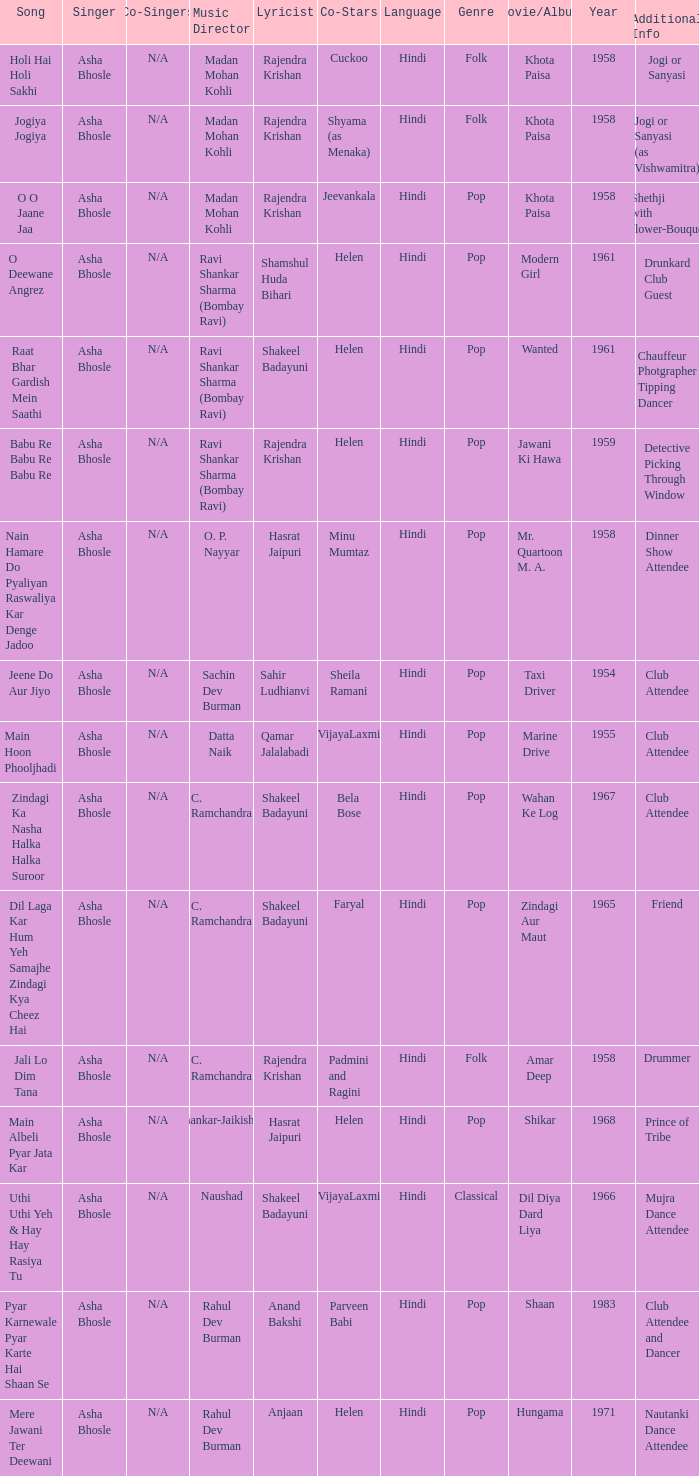Who sang for the movie Amar Deep? Asha Bhosle. 